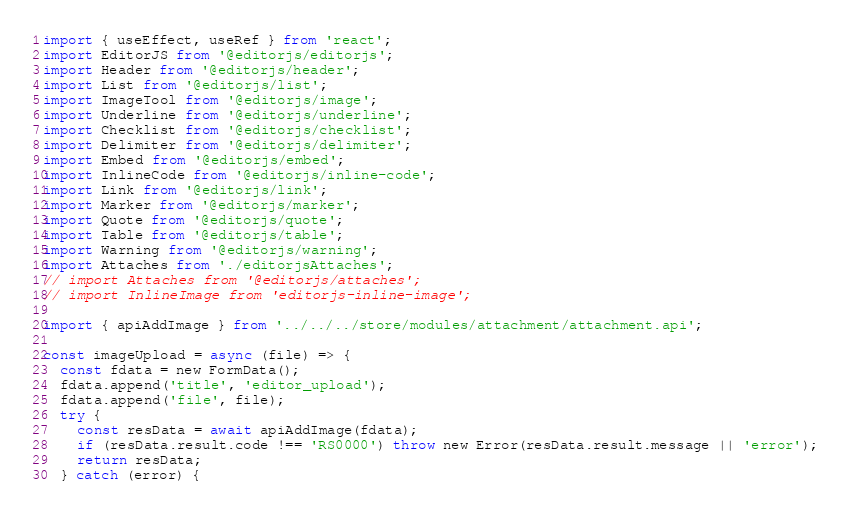Convert code to text. <code><loc_0><loc_0><loc_500><loc_500><_JavaScript_>import { useEffect, useRef } from 'react';
import EditorJS from '@editorjs/editorjs';
import Header from '@editorjs/header';
import List from '@editorjs/list';
import ImageTool from '@editorjs/image';
import Underline from '@editorjs/underline';
import Checklist from '@editorjs/checklist';
import Delimiter from '@editorjs/delimiter';
import Embed from '@editorjs/embed';
import InlineCode from '@editorjs/inline-code';
import Link from '@editorjs/link';
import Marker from '@editorjs/marker';
import Quote from '@editorjs/quote';
import Table from '@editorjs/table';
import Warning from '@editorjs/warning';
import Attaches from './editorjsAttaches';
// import Attaches from '@editorjs/attaches';
// import InlineImage from 'editorjs-inline-image';

import { apiAddImage } from '../../../store/modules/attachment/attachment.api';

const imageUpload = async (file) => {
  const fdata = new FormData();
  fdata.append('title', 'editor_upload');
  fdata.append('file', file);
  try {
    const resData = await apiAddImage(fdata);
    if (resData.result.code !== 'RS0000') throw new Error(resData.result.message || 'error');
    return resData;
  } catch (error) {</code> 